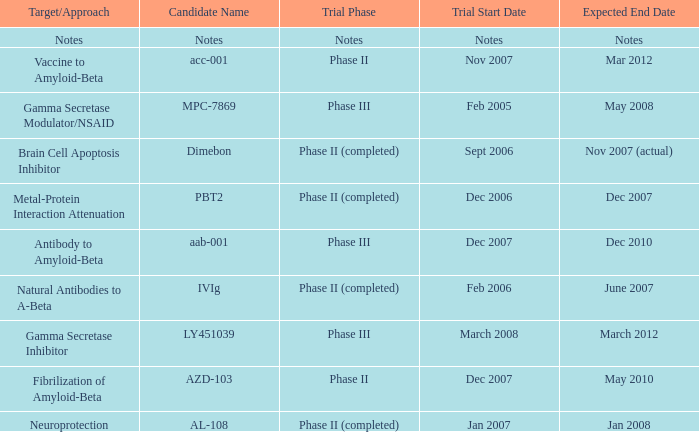What is Candidate Name, when Target/Approach is "vaccine to amyloid-beta"? Acc-001. 